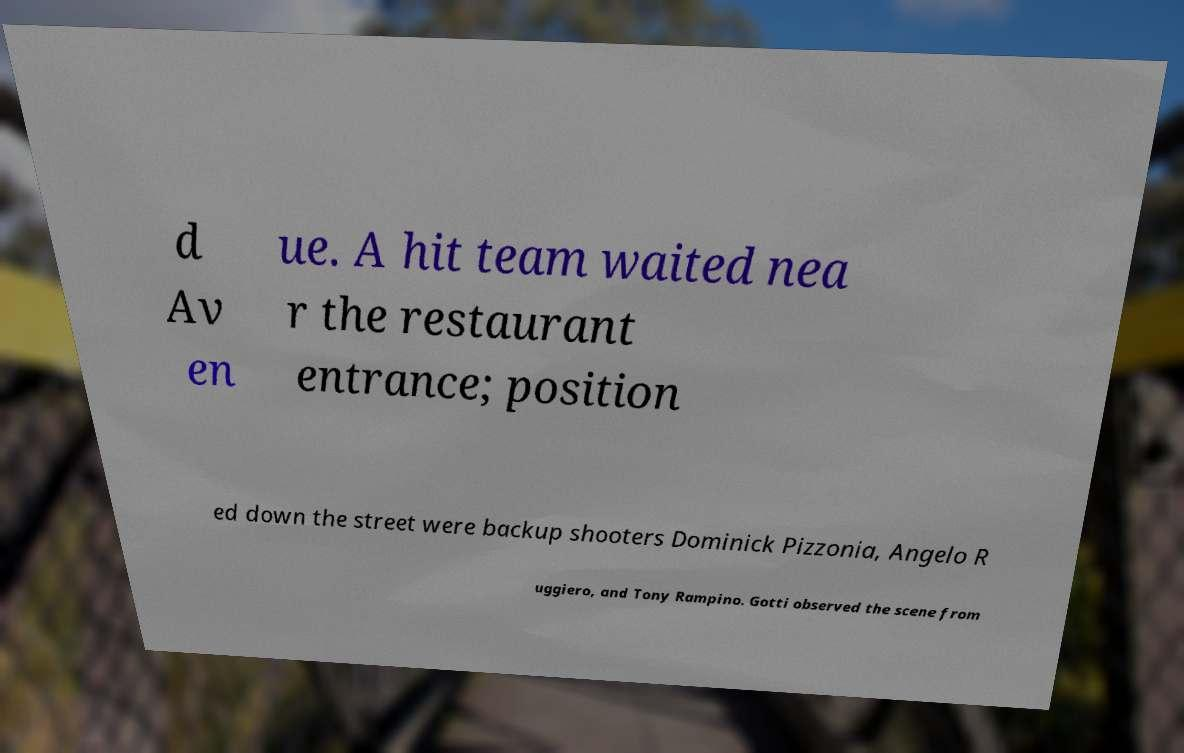Please read and relay the text visible in this image. What does it say? d Av en ue. A hit team waited nea r the restaurant entrance; position ed down the street were backup shooters Dominick Pizzonia, Angelo R uggiero, and Tony Rampino. Gotti observed the scene from 